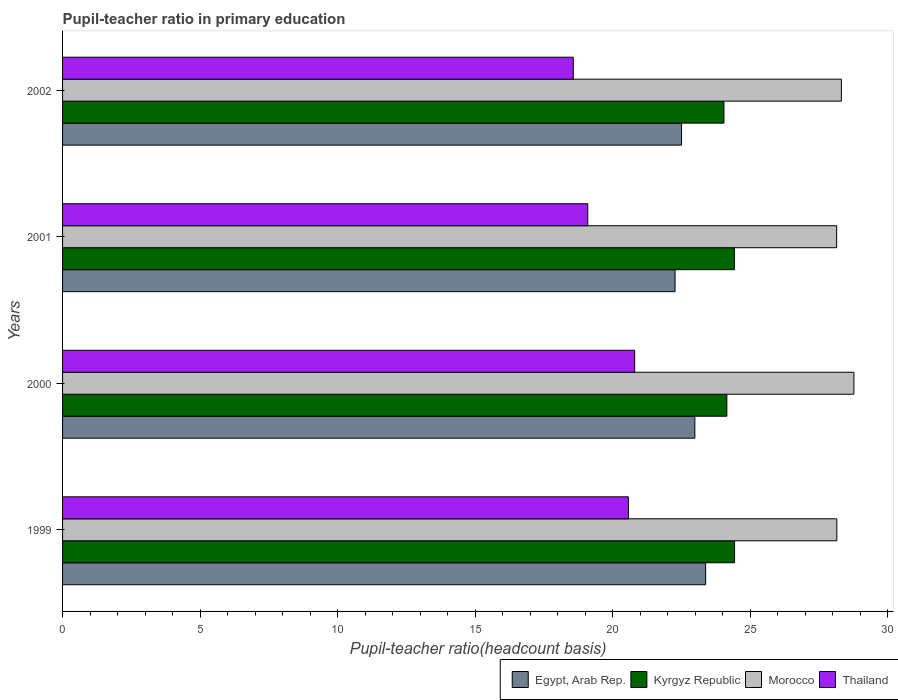How many bars are there on the 1st tick from the top?
Offer a very short reply. 4. What is the label of the 1st group of bars from the top?
Offer a terse response. 2002. What is the pupil-teacher ratio in primary education in Egypt, Arab Rep. in 2001?
Give a very brief answer. 22.26. Across all years, what is the maximum pupil-teacher ratio in primary education in Morocco?
Your response must be concise. 28.76. Across all years, what is the minimum pupil-teacher ratio in primary education in Morocco?
Your answer should be very brief. 28.13. In which year was the pupil-teacher ratio in primary education in Morocco minimum?
Your response must be concise. 2001. What is the total pupil-teacher ratio in primary education in Kyrgyz Republic in the graph?
Your answer should be compact. 97.03. What is the difference between the pupil-teacher ratio in primary education in Egypt, Arab Rep. in 2000 and that in 2002?
Your answer should be compact. 0.48. What is the difference between the pupil-teacher ratio in primary education in Kyrgyz Republic in 2001 and the pupil-teacher ratio in primary education in Egypt, Arab Rep. in 2002?
Offer a terse response. 1.92. What is the average pupil-teacher ratio in primary education in Kyrgyz Republic per year?
Give a very brief answer. 24.26. In the year 2000, what is the difference between the pupil-teacher ratio in primary education in Thailand and pupil-teacher ratio in primary education in Egypt, Arab Rep.?
Your answer should be compact. -2.19. What is the ratio of the pupil-teacher ratio in primary education in Egypt, Arab Rep. in 2001 to that in 2002?
Your answer should be very brief. 0.99. Is the pupil-teacher ratio in primary education in Thailand in 1999 less than that in 2001?
Provide a succinct answer. No. What is the difference between the highest and the second highest pupil-teacher ratio in primary education in Thailand?
Keep it short and to the point. 0.23. What is the difference between the highest and the lowest pupil-teacher ratio in primary education in Thailand?
Provide a short and direct response. 2.23. What does the 3rd bar from the top in 2002 represents?
Give a very brief answer. Kyrgyz Republic. What does the 2nd bar from the bottom in 1999 represents?
Ensure brevity in your answer.  Kyrgyz Republic. What is the difference between two consecutive major ticks on the X-axis?
Offer a terse response. 5. Are the values on the major ticks of X-axis written in scientific E-notation?
Offer a terse response. No. Where does the legend appear in the graph?
Offer a very short reply. Bottom right. How many legend labels are there?
Offer a very short reply. 4. How are the legend labels stacked?
Provide a short and direct response. Horizontal. What is the title of the graph?
Your answer should be very brief. Pupil-teacher ratio in primary education. What is the label or title of the X-axis?
Provide a short and direct response. Pupil-teacher ratio(headcount basis). What is the label or title of the Y-axis?
Offer a terse response. Years. What is the Pupil-teacher ratio(headcount basis) of Egypt, Arab Rep. in 1999?
Ensure brevity in your answer.  23.37. What is the Pupil-teacher ratio(headcount basis) of Kyrgyz Republic in 1999?
Your answer should be very brief. 24.42. What is the Pupil-teacher ratio(headcount basis) in Morocco in 1999?
Your answer should be compact. 28.14. What is the Pupil-teacher ratio(headcount basis) of Thailand in 1999?
Offer a terse response. 20.57. What is the Pupil-teacher ratio(headcount basis) of Egypt, Arab Rep. in 2000?
Make the answer very short. 22.98. What is the Pupil-teacher ratio(headcount basis) of Kyrgyz Republic in 2000?
Keep it short and to the point. 24.14. What is the Pupil-teacher ratio(headcount basis) of Morocco in 2000?
Offer a very short reply. 28.76. What is the Pupil-teacher ratio(headcount basis) in Thailand in 2000?
Offer a terse response. 20.79. What is the Pupil-teacher ratio(headcount basis) of Egypt, Arab Rep. in 2001?
Your answer should be compact. 22.26. What is the Pupil-teacher ratio(headcount basis) in Kyrgyz Republic in 2001?
Your answer should be compact. 24.42. What is the Pupil-teacher ratio(headcount basis) in Morocco in 2001?
Give a very brief answer. 28.13. What is the Pupil-teacher ratio(headcount basis) in Thailand in 2001?
Your response must be concise. 19.09. What is the Pupil-teacher ratio(headcount basis) in Egypt, Arab Rep. in 2002?
Keep it short and to the point. 22.5. What is the Pupil-teacher ratio(headcount basis) in Kyrgyz Republic in 2002?
Ensure brevity in your answer.  24.04. What is the Pupil-teacher ratio(headcount basis) in Morocco in 2002?
Keep it short and to the point. 28.31. What is the Pupil-teacher ratio(headcount basis) of Thailand in 2002?
Your answer should be very brief. 18.56. Across all years, what is the maximum Pupil-teacher ratio(headcount basis) in Egypt, Arab Rep.?
Offer a very short reply. 23.37. Across all years, what is the maximum Pupil-teacher ratio(headcount basis) in Kyrgyz Republic?
Offer a very short reply. 24.42. Across all years, what is the maximum Pupil-teacher ratio(headcount basis) of Morocco?
Your answer should be very brief. 28.76. Across all years, what is the maximum Pupil-teacher ratio(headcount basis) in Thailand?
Make the answer very short. 20.79. Across all years, what is the minimum Pupil-teacher ratio(headcount basis) of Egypt, Arab Rep.?
Provide a succinct answer. 22.26. Across all years, what is the minimum Pupil-teacher ratio(headcount basis) in Kyrgyz Republic?
Keep it short and to the point. 24.04. Across all years, what is the minimum Pupil-teacher ratio(headcount basis) in Morocco?
Your response must be concise. 28.13. Across all years, what is the minimum Pupil-teacher ratio(headcount basis) of Thailand?
Provide a short and direct response. 18.56. What is the total Pupil-teacher ratio(headcount basis) of Egypt, Arab Rep. in the graph?
Provide a short and direct response. 91.11. What is the total Pupil-teacher ratio(headcount basis) in Kyrgyz Republic in the graph?
Provide a succinct answer. 97.03. What is the total Pupil-teacher ratio(headcount basis) of Morocco in the graph?
Provide a short and direct response. 113.35. What is the total Pupil-teacher ratio(headcount basis) of Thailand in the graph?
Your answer should be very brief. 79.01. What is the difference between the Pupil-teacher ratio(headcount basis) in Egypt, Arab Rep. in 1999 and that in 2000?
Your response must be concise. 0.39. What is the difference between the Pupil-teacher ratio(headcount basis) of Kyrgyz Republic in 1999 and that in 2000?
Provide a succinct answer. 0.28. What is the difference between the Pupil-teacher ratio(headcount basis) of Morocco in 1999 and that in 2000?
Your response must be concise. -0.62. What is the difference between the Pupil-teacher ratio(headcount basis) of Thailand in 1999 and that in 2000?
Offer a very short reply. -0.23. What is the difference between the Pupil-teacher ratio(headcount basis) of Egypt, Arab Rep. in 1999 and that in 2001?
Provide a short and direct response. 1.11. What is the difference between the Pupil-teacher ratio(headcount basis) in Kyrgyz Republic in 1999 and that in 2001?
Keep it short and to the point. 0.01. What is the difference between the Pupil-teacher ratio(headcount basis) of Morocco in 1999 and that in 2001?
Make the answer very short. 0.01. What is the difference between the Pupil-teacher ratio(headcount basis) of Thailand in 1999 and that in 2001?
Provide a succinct answer. 1.48. What is the difference between the Pupil-teacher ratio(headcount basis) in Egypt, Arab Rep. in 1999 and that in 2002?
Give a very brief answer. 0.88. What is the difference between the Pupil-teacher ratio(headcount basis) of Kyrgyz Republic in 1999 and that in 2002?
Give a very brief answer. 0.39. What is the difference between the Pupil-teacher ratio(headcount basis) of Morocco in 1999 and that in 2002?
Offer a very short reply. -0.17. What is the difference between the Pupil-teacher ratio(headcount basis) of Thailand in 1999 and that in 2002?
Provide a short and direct response. 2. What is the difference between the Pupil-teacher ratio(headcount basis) of Egypt, Arab Rep. in 2000 and that in 2001?
Offer a very short reply. 0.72. What is the difference between the Pupil-teacher ratio(headcount basis) of Kyrgyz Republic in 2000 and that in 2001?
Make the answer very short. -0.27. What is the difference between the Pupil-teacher ratio(headcount basis) of Morocco in 2000 and that in 2001?
Give a very brief answer. 0.63. What is the difference between the Pupil-teacher ratio(headcount basis) in Thailand in 2000 and that in 2001?
Ensure brevity in your answer.  1.7. What is the difference between the Pupil-teacher ratio(headcount basis) in Egypt, Arab Rep. in 2000 and that in 2002?
Provide a short and direct response. 0.48. What is the difference between the Pupil-teacher ratio(headcount basis) in Kyrgyz Republic in 2000 and that in 2002?
Provide a succinct answer. 0.11. What is the difference between the Pupil-teacher ratio(headcount basis) of Morocco in 2000 and that in 2002?
Make the answer very short. 0.46. What is the difference between the Pupil-teacher ratio(headcount basis) of Thailand in 2000 and that in 2002?
Provide a short and direct response. 2.23. What is the difference between the Pupil-teacher ratio(headcount basis) of Egypt, Arab Rep. in 2001 and that in 2002?
Keep it short and to the point. -0.24. What is the difference between the Pupil-teacher ratio(headcount basis) in Kyrgyz Republic in 2001 and that in 2002?
Offer a very short reply. 0.38. What is the difference between the Pupil-teacher ratio(headcount basis) in Morocco in 2001 and that in 2002?
Your response must be concise. -0.17. What is the difference between the Pupil-teacher ratio(headcount basis) in Thailand in 2001 and that in 2002?
Keep it short and to the point. 0.53. What is the difference between the Pupil-teacher ratio(headcount basis) of Egypt, Arab Rep. in 1999 and the Pupil-teacher ratio(headcount basis) of Kyrgyz Republic in 2000?
Keep it short and to the point. -0.77. What is the difference between the Pupil-teacher ratio(headcount basis) of Egypt, Arab Rep. in 1999 and the Pupil-teacher ratio(headcount basis) of Morocco in 2000?
Make the answer very short. -5.39. What is the difference between the Pupil-teacher ratio(headcount basis) of Egypt, Arab Rep. in 1999 and the Pupil-teacher ratio(headcount basis) of Thailand in 2000?
Make the answer very short. 2.58. What is the difference between the Pupil-teacher ratio(headcount basis) in Kyrgyz Republic in 1999 and the Pupil-teacher ratio(headcount basis) in Morocco in 2000?
Provide a short and direct response. -4.34. What is the difference between the Pupil-teacher ratio(headcount basis) of Kyrgyz Republic in 1999 and the Pupil-teacher ratio(headcount basis) of Thailand in 2000?
Offer a terse response. 3.63. What is the difference between the Pupil-teacher ratio(headcount basis) of Morocco in 1999 and the Pupil-teacher ratio(headcount basis) of Thailand in 2000?
Provide a succinct answer. 7.35. What is the difference between the Pupil-teacher ratio(headcount basis) in Egypt, Arab Rep. in 1999 and the Pupil-teacher ratio(headcount basis) in Kyrgyz Republic in 2001?
Offer a terse response. -1.05. What is the difference between the Pupil-teacher ratio(headcount basis) in Egypt, Arab Rep. in 1999 and the Pupil-teacher ratio(headcount basis) in Morocco in 2001?
Ensure brevity in your answer.  -4.76. What is the difference between the Pupil-teacher ratio(headcount basis) of Egypt, Arab Rep. in 1999 and the Pupil-teacher ratio(headcount basis) of Thailand in 2001?
Make the answer very short. 4.28. What is the difference between the Pupil-teacher ratio(headcount basis) of Kyrgyz Republic in 1999 and the Pupil-teacher ratio(headcount basis) of Morocco in 2001?
Make the answer very short. -3.71. What is the difference between the Pupil-teacher ratio(headcount basis) of Kyrgyz Republic in 1999 and the Pupil-teacher ratio(headcount basis) of Thailand in 2001?
Your answer should be compact. 5.34. What is the difference between the Pupil-teacher ratio(headcount basis) of Morocco in 1999 and the Pupil-teacher ratio(headcount basis) of Thailand in 2001?
Provide a succinct answer. 9.05. What is the difference between the Pupil-teacher ratio(headcount basis) in Egypt, Arab Rep. in 1999 and the Pupil-teacher ratio(headcount basis) in Kyrgyz Republic in 2002?
Your response must be concise. -0.67. What is the difference between the Pupil-teacher ratio(headcount basis) in Egypt, Arab Rep. in 1999 and the Pupil-teacher ratio(headcount basis) in Morocco in 2002?
Provide a succinct answer. -4.94. What is the difference between the Pupil-teacher ratio(headcount basis) of Egypt, Arab Rep. in 1999 and the Pupil-teacher ratio(headcount basis) of Thailand in 2002?
Provide a succinct answer. 4.81. What is the difference between the Pupil-teacher ratio(headcount basis) in Kyrgyz Republic in 1999 and the Pupil-teacher ratio(headcount basis) in Morocco in 2002?
Make the answer very short. -3.88. What is the difference between the Pupil-teacher ratio(headcount basis) in Kyrgyz Republic in 1999 and the Pupil-teacher ratio(headcount basis) in Thailand in 2002?
Your answer should be compact. 5.86. What is the difference between the Pupil-teacher ratio(headcount basis) in Morocco in 1999 and the Pupil-teacher ratio(headcount basis) in Thailand in 2002?
Ensure brevity in your answer.  9.58. What is the difference between the Pupil-teacher ratio(headcount basis) in Egypt, Arab Rep. in 2000 and the Pupil-teacher ratio(headcount basis) in Kyrgyz Republic in 2001?
Give a very brief answer. -1.44. What is the difference between the Pupil-teacher ratio(headcount basis) of Egypt, Arab Rep. in 2000 and the Pupil-teacher ratio(headcount basis) of Morocco in 2001?
Keep it short and to the point. -5.15. What is the difference between the Pupil-teacher ratio(headcount basis) in Egypt, Arab Rep. in 2000 and the Pupil-teacher ratio(headcount basis) in Thailand in 2001?
Your answer should be compact. 3.89. What is the difference between the Pupil-teacher ratio(headcount basis) of Kyrgyz Republic in 2000 and the Pupil-teacher ratio(headcount basis) of Morocco in 2001?
Keep it short and to the point. -3.99. What is the difference between the Pupil-teacher ratio(headcount basis) of Kyrgyz Republic in 2000 and the Pupil-teacher ratio(headcount basis) of Thailand in 2001?
Offer a very short reply. 5.06. What is the difference between the Pupil-teacher ratio(headcount basis) in Morocco in 2000 and the Pupil-teacher ratio(headcount basis) in Thailand in 2001?
Give a very brief answer. 9.67. What is the difference between the Pupil-teacher ratio(headcount basis) of Egypt, Arab Rep. in 2000 and the Pupil-teacher ratio(headcount basis) of Kyrgyz Republic in 2002?
Ensure brevity in your answer.  -1.06. What is the difference between the Pupil-teacher ratio(headcount basis) of Egypt, Arab Rep. in 2000 and the Pupil-teacher ratio(headcount basis) of Morocco in 2002?
Provide a succinct answer. -5.33. What is the difference between the Pupil-teacher ratio(headcount basis) of Egypt, Arab Rep. in 2000 and the Pupil-teacher ratio(headcount basis) of Thailand in 2002?
Ensure brevity in your answer.  4.42. What is the difference between the Pupil-teacher ratio(headcount basis) in Kyrgyz Republic in 2000 and the Pupil-teacher ratio(headcount basis) in Morocco in 2002?
Ensure brevity in your answer.  -4.16. What is the difference between the Pupil-teacher ratio(headcount basis) of Kyrgyz Republic in 2000 and the Pupil-teacher ratio(headcount basis) of Thailand in 2002?
Ensure brevity in your answer.  5.58. What is the difference between the Pupil-teacher ratio(headcount basis) of Morocco in 2000 and the Pupil-teacher ratio(headcount basis) of Thailand in 2002?
Your answer should be very brief. 10.2. What is the difference between the Pupil-teacher ratio(headcount basis) of Egypt, Arab Rep. in 2001 and the Pupil-teacher ratio(headcount basis) of Kyrgyz Republic in 2002?
Provide a succinct answer. -1.78. What is the difference between the Pupil-teacher ratio(headcount basis) in Egypt, Arab Rep. in 2001 and the Pupil-teacher ratio(headcount basis) in Morocco in 2002?
Provide a succinct answer. -6.05. What is the difference between the Pupil-teacher ratio(headcount basis) in Egypt, Arab Rep. in 2001 and the Pupil-teacher ratio(headcount basis) in Thailand in 2002?
Provide a short and direct response. 3.7. What is the difference between the Pupil-teacher ratio(headcount basis) of Kyrgyz Republic in 2001 and the Pupil-teacher ratio(headcount basis) of Morocco in 2002?
Provide a short and direct response. -3.89. What is the difference between the Pupil-teacher ratio(headcount basis) in Kyrgyz Republic in 2001 and the Pupil-teacher ratio(headcount basis) in Thailand in 2002?
Ensure brevity in your answer.  5.86. What is the difference between the Pupil-teacher ratio(headcount basis) in Morocco in 2001 and the Pupil-teacher ratio(headcount basis) in Thailand in 2002?
Provide a succinct answer. 9.57. What is the average Pupil-teacher ratio(headcount basis) in Egypt, Arab Rep. per year?
Ensure brevity in your answer.  22.78. What is the average Pupil-teacher ratio(headcount basis) of Kyrgyz Republic per year?
Your answer should be compact. 24.26. What is the average Pupil-teacher ratio(headcount basis) in Morocco per year?
Ensure brevity in your answer.  28.34. What is the average Pupil-teacher ratio(headcount basis) in Thailand per year?
Offer a very short reply. 19.75. In the year 1999, what is the difference between the Pupil-teacher ratio(headcount basis) in Egypt, Arab Rep. and Pupil-teacher ratio(headcount basis) in Kyrgyz Republic?
Keep it short and to the point. -1.05. In the year 1999, what is the difference between the Pupil-teacher ratio(headcount basis) in Egypt, Arab Rep. and Pupil-teacher ratio(headcount basis) in Morocco?
Ensure brevity in your answer.  -4.77. In the year 1999, what is the difference between the Pupil-teacher ratio(headcount basis) of Egypt, Arab Rep. and Pupil-teacher ratio(headcount basis) of Thailand?
Offer a very short reply. 2.81. In the year 1999, what is the difference between the Pupil-teacher ratio(headcount basis) of Kyrgyz Republic and Pupil-teacher ratio(headcount basis) of Morocco?
Offer a very short reply. -3.72. In the year 1999, what is the difference between the Pupil-teacher ratio(headcount basis) of Kyrgyz Republic and Pupil-teacher ratio(headcount basis) of Thailand?
Your answer should be very brief. 3.86. In the year 1999, what is the difference between the Pupil-teacher ratio(headcount basis) in Morocco and Pupil-teacher ratio(headcount basis) in Thailand?
Your answer should be very brief. 7.57. In the year 2000, what is the difference between the Pupil-teacher ratio(headcount basis) in Egypt, Arab Rep. and Pupil-teacher ratio(headcount basis) in Kyrgyz Republic?
Your response must be concise. -1.16. In the year 2000, what is the difference between the Pupil-teacher ratio(headcount basis) in Egypt, Arab Rep. and Pupil-teacher ratio(headcount basis) in Morocco?
Offer a terse response. -5.78. In the year 2000, what is the difference between the Pupil-teacher ratio(headcount basis) in Egypt, Arab Rep. and Pupil-teacher ratio(headcount basis) in Thailand?
Provide a succinct answer. 2.19. In the year 2000, what is the difference between the Pupil-teacher ratio(headcount basis) in Kyrgyz Republic and Pupil-teacher ratio(headcount basis) in Morocco?
Ensure brevity in your answer.  -4.62. In the year 2000, what is the difference between the Pupil-teacher ratio(headcount basis) of Kyrgyz Republic and Pupil-teacher ratio(headcount basis) of Thailand?
Give a very brief answer. 3.35. In the year 2000, what is the difference between the Pupil-teacher ratio(headcount basis) of Morocco and Pupil-teacher ratio(headcount basis) of Thailand?
Provide a succinct answer. 7.97. In the year 2001, what is the difference between the Pupil-teacher ratio(headcount basis) of Egypt, Arab Rep. and Pupil-teacher ratio(headcount basis) of Kyrgyz Republic?
Ensure brevity in your answer.  -2.16. In the year 2001, what is the difference between the Pupil-teacher ratio(headcount basis) of Egypt, Arab Rep. and Pupil-teacher ratio(headcount basis) of Morocco?
Offer a terse response. -5.87. In the year 2001, what is the difference between the Pupil-teacher ratio(headcount basis) in Egypt, Arab Rep. and Pupil-teacher ratio(headcount basis) in Thailand?
Ensure brevity in your answer.  3.17. In the year 2001, what is the difference between the Pupil-teacher ratio(headcount basis) in Kyrgyz Republic and Pupil-teacher ratio(headcount basis) in Morocco?
Provide a succinct answer. -3.72. In the year 2001, what is the difference between the Pupil-teacher ratio(headcount basis) of Kyrgyz Republic and Pupil-teacher ratio(headcount basis) of Thailand?
Your answer should be compact. 5.33. In the year 2001, what is the difference between the Pupil-teacher ratio(headcount basis) of Morocco and Pupil-teacher ratio(headcount basis) of Thailand?
Your answer should be very brief. 9.05. In the year 2002, what is the difference between the Pupil-teacher ratio(headcount basis) in Egypt, Arab Rep. and Pupil-teacher ratio(headcount basis) in Kyrgyz Republic?
Provide a short and direct response. -1.54. In the year 2002, what is the difference between the Pupil-teacher ratio(headcount basis) of Egypt, Arab Rep. and Pupil-teacher ratio(headcount basis) of Morocco?
Make the answer very short. -5.81. In the year 2002, what is the difference between the Pupil-teacher ratio(headcount basis) in Egypt, Arab Rep. and Pupil-teacher ratio(headcount basis) in Thailand?
Provide a short and direct response. 3.93. In the year 2002, what is the difference between the Pupil-teacher ratio(headcount basis) of Kyrgyz Republic and Pupil-teacher ratio(headcount basis) of Morocco?
Offer a very short reply. -4.27. In the year 2002, what is the difference between the Pupil-teacher ratio(headcount basis) of Kyrgyz Republic and Pupil-teacher ratio(headcount basis) of Thailand?
Give a very brief answer. 5.48. In the year 2002, what is the difference between the Pupil-teacher ratio(headcount basis) in Morocco and Pupil-teacher ratio(headcount basis) in Thailand?
Your answer should be compact. 9.74. What is the ratio of the Pupil-teacher ratio(headcount basis) in Kyrgyz Republic in 1999 to that in 2000?
Make the answer very short. 1.01. What is the ratio of the Pupil-teacher ratio(headcount basis) in Morocco in 1999 to that in 2000?
Make the answer very short. 0.98. What is the ratio of the Pupil-teacher ratio(headcount basis) in Egypt, Arab Rep. in 1999 to that in 2001?
Offer a very short reply. 1.05. What is the ratio of the Pupil-teacher ratio(headcount basis) in Kyrgyz Republic in 1999 to that in 2001?
Your response must be concise. 1. What is the ratio of the Pupil-teacher ratio(headcount basis) of Thailand in 1999 to that in 2001?
Provide a succinct answer. 1.08. What is the ratio of the Pupil-teacher ratio(headcount basis) in Egypt, Arab Rep. in 1999 to that in 2002?
Provide a short and direct response. 1.04. What is the ratio of the Pupil-teacher ratio(headcount basis) in Kyrgyz Republic in 1999 to that in 2002?
Your answer should be compact. 1.02. What is the ratio of the Pupil-teacher ratio(headcount basis) of Morocco in 1999 to that in 2002?
Ensure brevity in your answer.  0.99. What is the ratio of the Pupil-teacher ratio(headcount basis) of Thailand in 1999 to that in 2002?
Ensure brevity in your answer.  1.11. What is the ratio of the Pupil-teacher ratio(headcount basis) in Egypt, Arab Rep. in 2000 to that in 2001?
Offer a terse response. 1.03. What is the ratio of the Pupil-teacher ratio(headcount basis) of Kyrgyz Republic in 2000 to that in 2001?
Your response must be concise. 0.99. What is the ratio of the Pupil-teacher ratio(headcount basis) in Morocco in 2000 to that in 2001?
Keep it short and to the point. 1.02. What is the ratio of the Pupil-teacher ratio(headcount basis) in Thailand in 2000 to that in 2001?
Your answer should be very brief. 1.09. What is the ratio of the Pupil-teacher ratio(headcount basis) of Egypt, Arab Rep. in 2000 to that in 2002?
Your answer should be very brief. 1.02. What is the ratio of the Pupil-teacher ratio(headcount basis) in Kyrgyz Republic in 2000 to that in 2002?
Make the answer very short. 1. What is the ratio of the Pupil-teacher ratio(headcount basis) of Morocco in 2000 to that in 2002?
Keep it short and to the point. 1.02. What is the ratio of the Pupil-teacher ratio(headcount basis) of Thailand in 2000 to that in 2002?
Offer a terse response. 1.12. What is the ratio of the Pupil-teacher ratio(headcount basis) of Egypt, Arab Rep. in 2001 to that in 2002?
Give a very brief answer. 0.99. What is the ratio of the Pupil-teacher ratio(headcount basis) in Kyrgyz Republic in 2001 to that in 2002?
Offer a very short reply. 1.02. What is the ratio of the Pupil-teacher ratio(headcount basis) in Morocco in 2001 to that in 2002?
Your answer should be very brief. 0.99. What is the ratio of the Pupil-teacher ratio(headcount basis) of Thailand in 2001 to that in 2002?
Your answer should be very brief. 1.03. What is the difference between the highest and the second highest Pupil-teacher ratio(headcount basis) of Egypt, Arab Rep.?
Your response must be concise. 0.39. What is the difference between the highest and the second highest Pupil-teacher ratio(headcount basis) in Kyrgyz Republic?
Provide a succinct answer. 0.01. What is the difference between the highest and the second highest Pupil-teacher ratio(headcount basis) of Morocco?
Offer a very short reply. 0.46. What is the difference between the highest and the second highest Pupil-teacher ratio(headcount basis) in Thailand?
Keep it short and to the point. 0.23. What is the difference between the highest and the lowest Pupil-teacher ratio(headcount basis) of Egypt, Arab Rep.?
Give a very brief answer. 1.11. What is the difference between the highest and the lowest Pupil-teacher ratio(headcount basis) of Kyrgyz Republic?
Offer a very short reply. 0.39. What is the difference between the highest and the lowest Pupil-teacher ratio(headcount basis) of Morocco?
Your answer should be very brief. 0.63. What is the difference between the highest and the lowest Pupil-teacher ratio(headcount basis) in Thailand?
Keep it short and to the point. 2.23. 